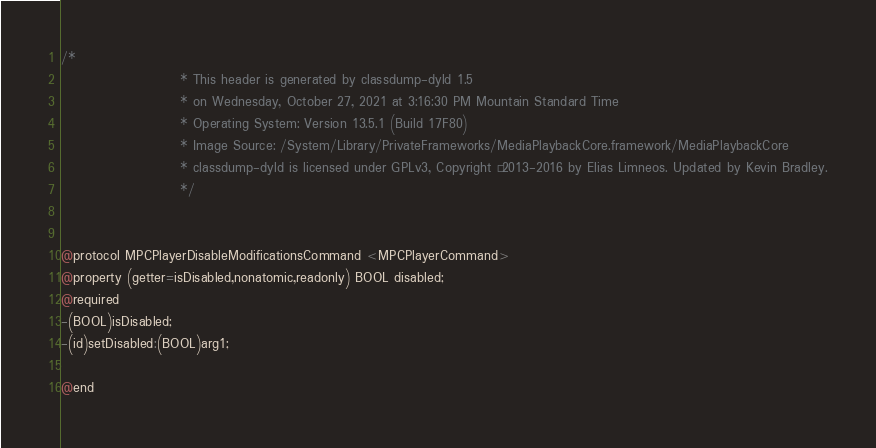<code> <loc_0><loc_0><loc_500><loc_500><_C_>/*
                       * This header is generated by classdump-dyld 1.5
                       * on Wednesday, October 27, 2021 at 3:16:30 PM Mountain Standard Time
                       * Operating System: Version 13.5.1 (Build 17F80)
                       * Image Source: /System/Library/PrivateFrameworks/MediaPlaybackCore.framework/MediaPlaybackCore
                       * classdump-dyld is licensed under GPLv3, Copyright © 2013-2016 by Elias Limneos. Updated by Kevin Bradley.
                       */


@protocol MPCPlayerDisableModificationsCommand <MPCPlayerCommand>
@property (getter=isDisabled,nonatomic,readonly) BOOL disabled; 
@required
-(BOOL)isDisabled;
-(id)setDisabled:(BOOL)arg1;

@end

</code> 